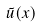<formula> <loc_0><loc_0><loc_500><loc_500>\tilde { u } ( x )</formula> 